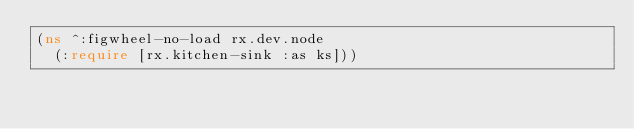Convert code to text. <code><loc_0><loc_0><loc_500><loc_500><_Clojure_>(ns ^:figwheel-no-load rx.dev.node
  (:require [rx.kitchen-sink :as ks]))
</code> 